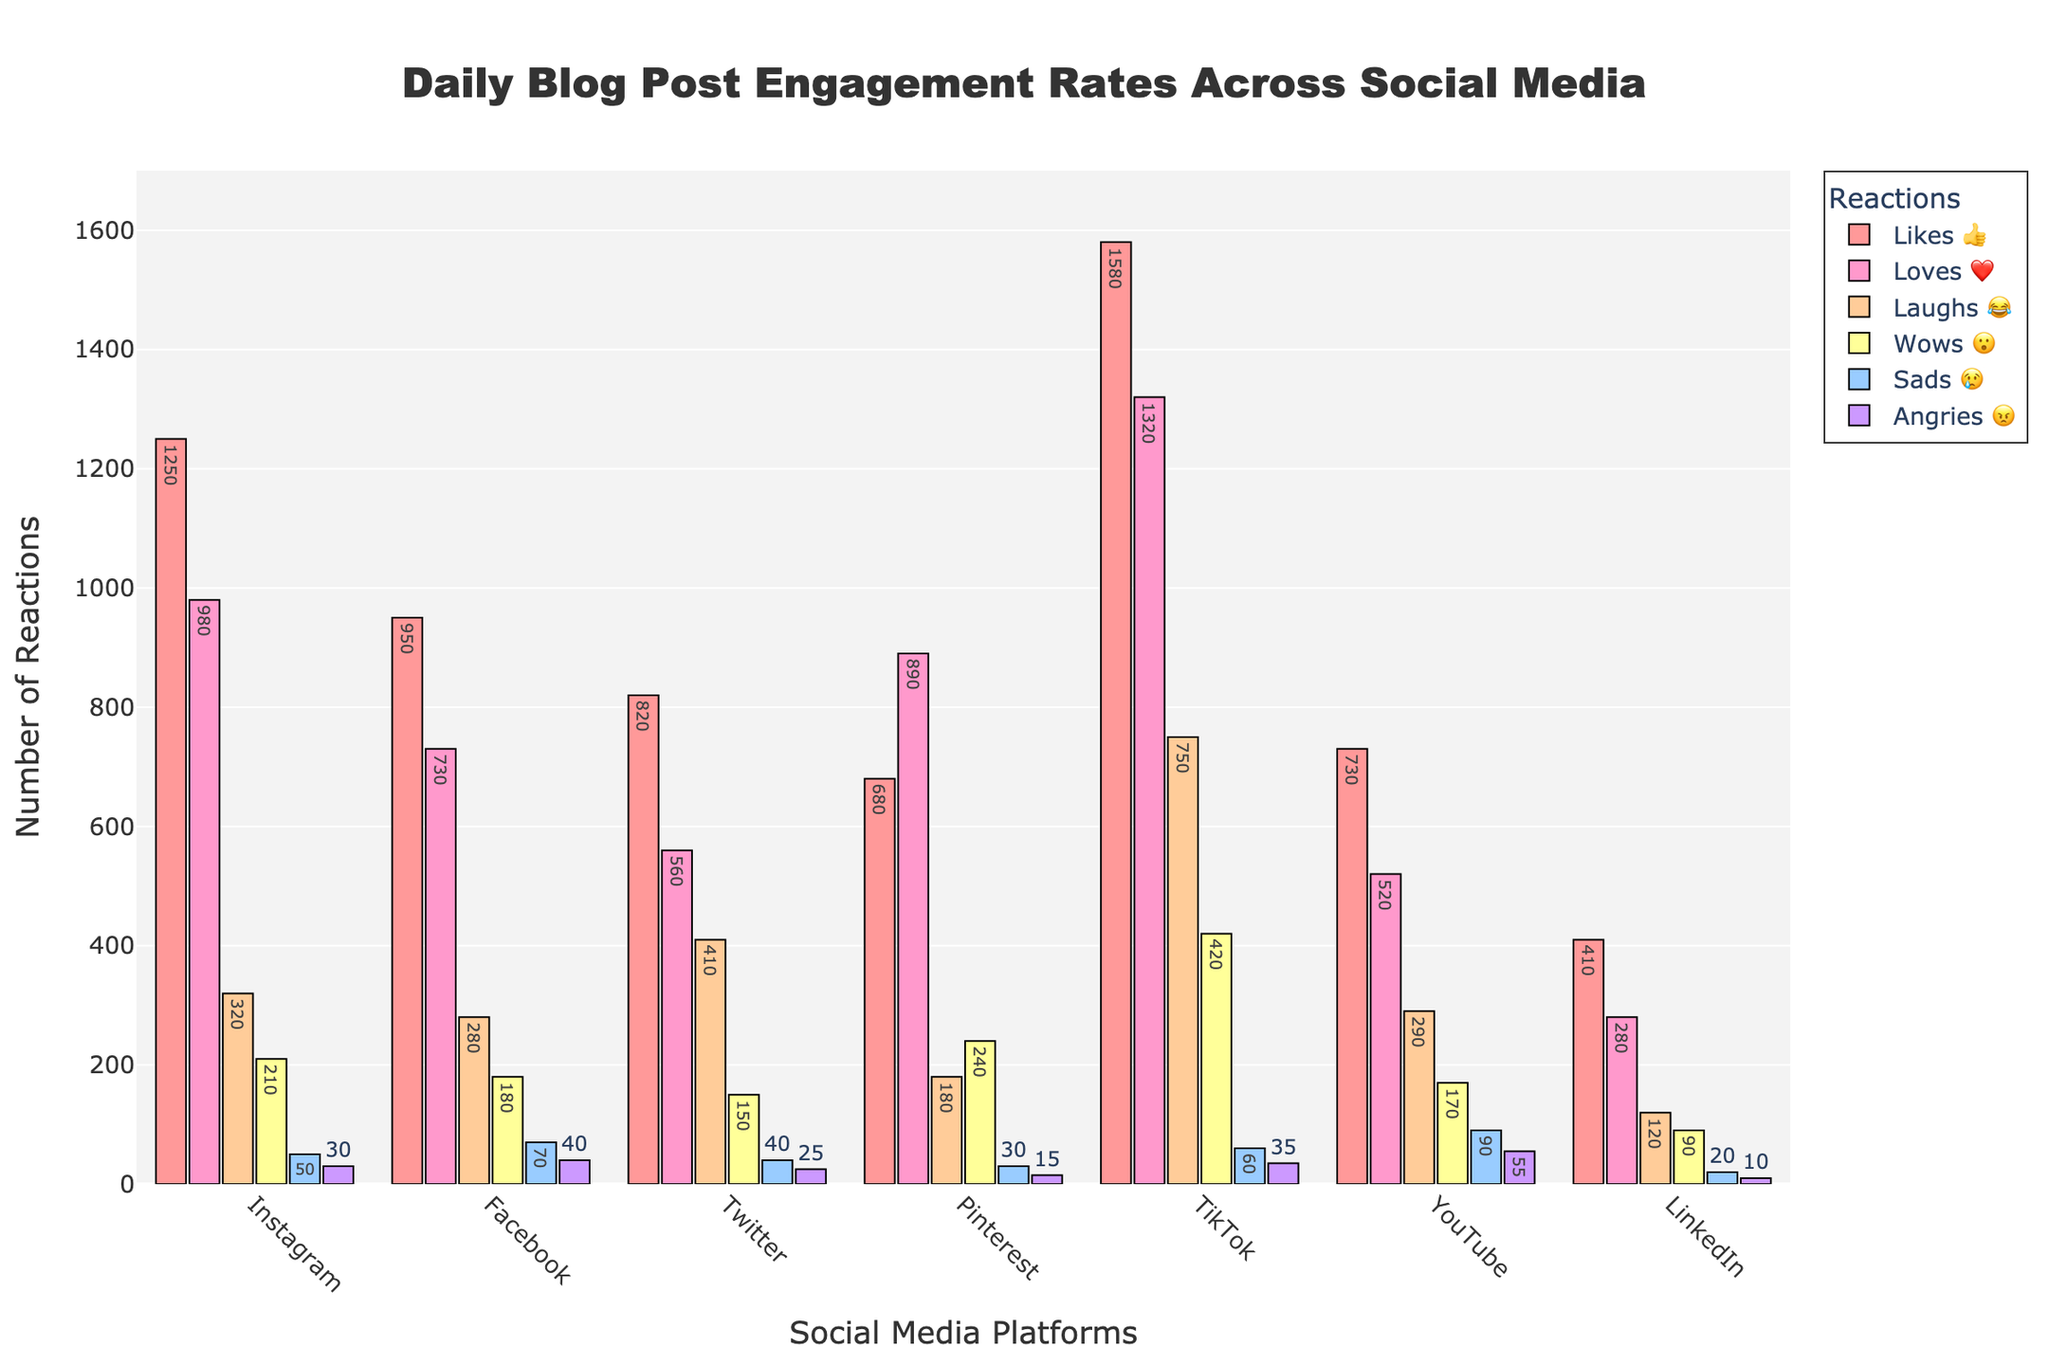What's the title of the chart? The title of the chart is typically displayed at the top of the figure. Here, it reads "Daily Blog Post Engagement Rates Across Social Media".
Answer: Daily Blog Post Engagement Rates Across Social Media Which platform has the highest number of "Likes 👍"? Look at the bar representing "Likes 👍" and identify the tallest bar. Here, TikTok has the tallest bar for "Likes 👍".
Answer: TikTok How many "Angries 😠" reactions did LinkedIn receive? Check the "Angries 😠" bar for LinkedIn and read the value displayed on top. LinkedIn has 10 "Angries 😠" reactions.
Answer: 10 What platform has the highest combined reactions for "Loves ❤️" and "Laughs 😂"? Sum the "Loves ❤️" and "Laughs 😂" reactions for each platform and determine the highest sum. TikTok has the highest sum with 1320 + 750 = 2070.
Answer: TikTok Which platform has fewer "Wows 😮", Instagram or YouTube? Compare the "Wows 😮" bar for Instagram (210) and YouTube (170) to see which is lower. YouTube has fewer "Wows 😮".
Answer: YouTube What is the difference in "Laughs 😂" reactions between TikTok and Twitter? Subtract the "Laughs 😂" reactions of Twitter (410) from TikTok (750). The difference is 750 - 410 = 340.
Answer: 340 Which platform has the least number of "Loves ❤️"? Find the shortest bar in the "Loves ❤️" category. LinkedIn, with 280 "Loves ❤️", has the least.
Answer: LinkedIn On which platform are "Sads 😢" reactions higher than "Wows 😮"? Identify the platforms where the "Sads 😢" bar is taller than the "Wows 😮" bar. Only YouTube meets this criterion with 90 "Sads 😢" and 170 "Wows 😮".
Answer: YouTube Which platform ranks third in terms of "Likes 👍"? Rank the "Likes 👍" bars. Facebook, with 950 "Likes 👍", follows TikTok and Instagram.
Answer: Facebook 